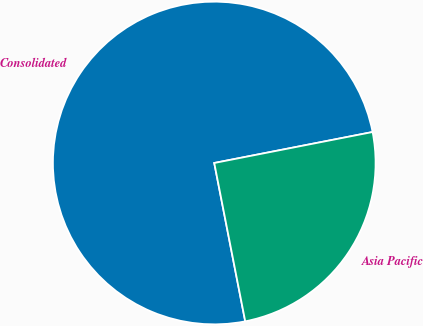<chart> <loc_0><loc_0><loc_500><loc_500><pie_chart><fcel>Consolidated<fcel>Asia Pacific<nl><fcel>75.0%<fcel>25.0%<nl></chart> 